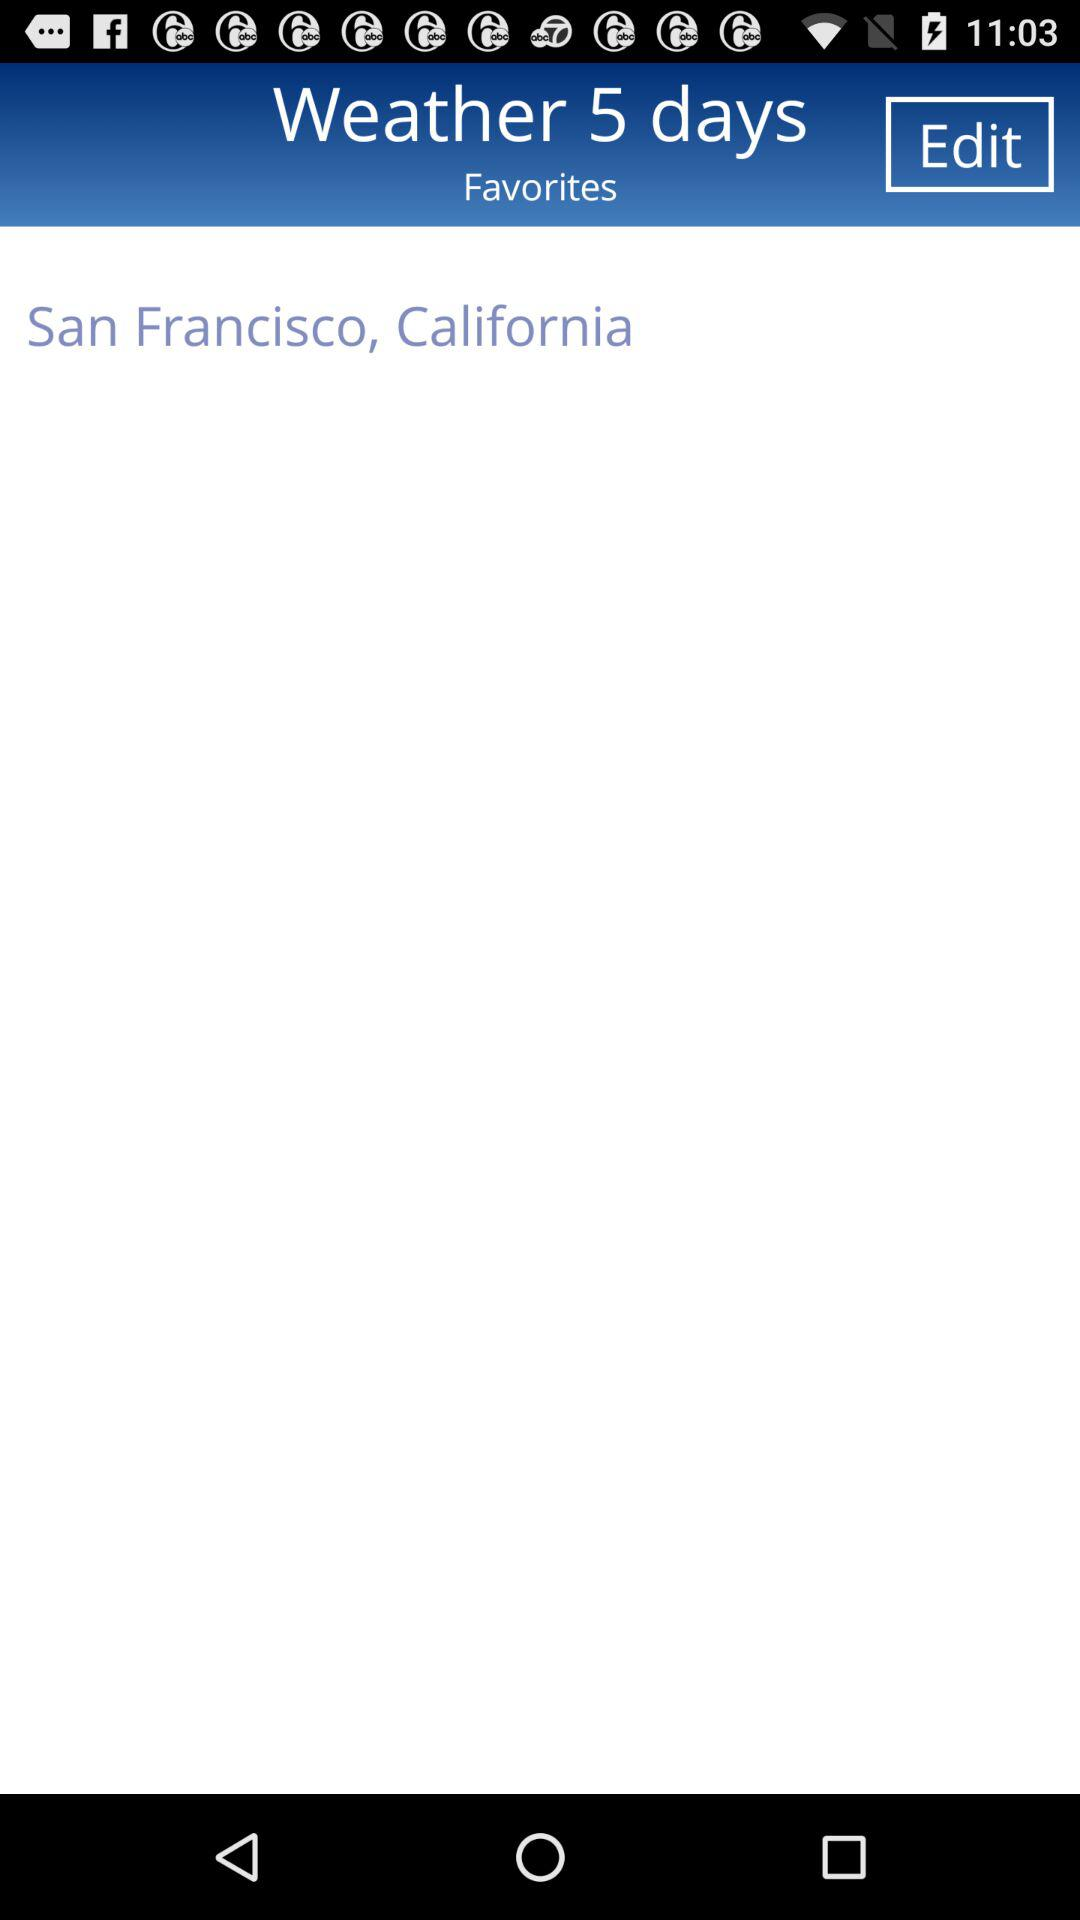What location is shown on the screen? The location shown on the screen is San Francisco, California. 